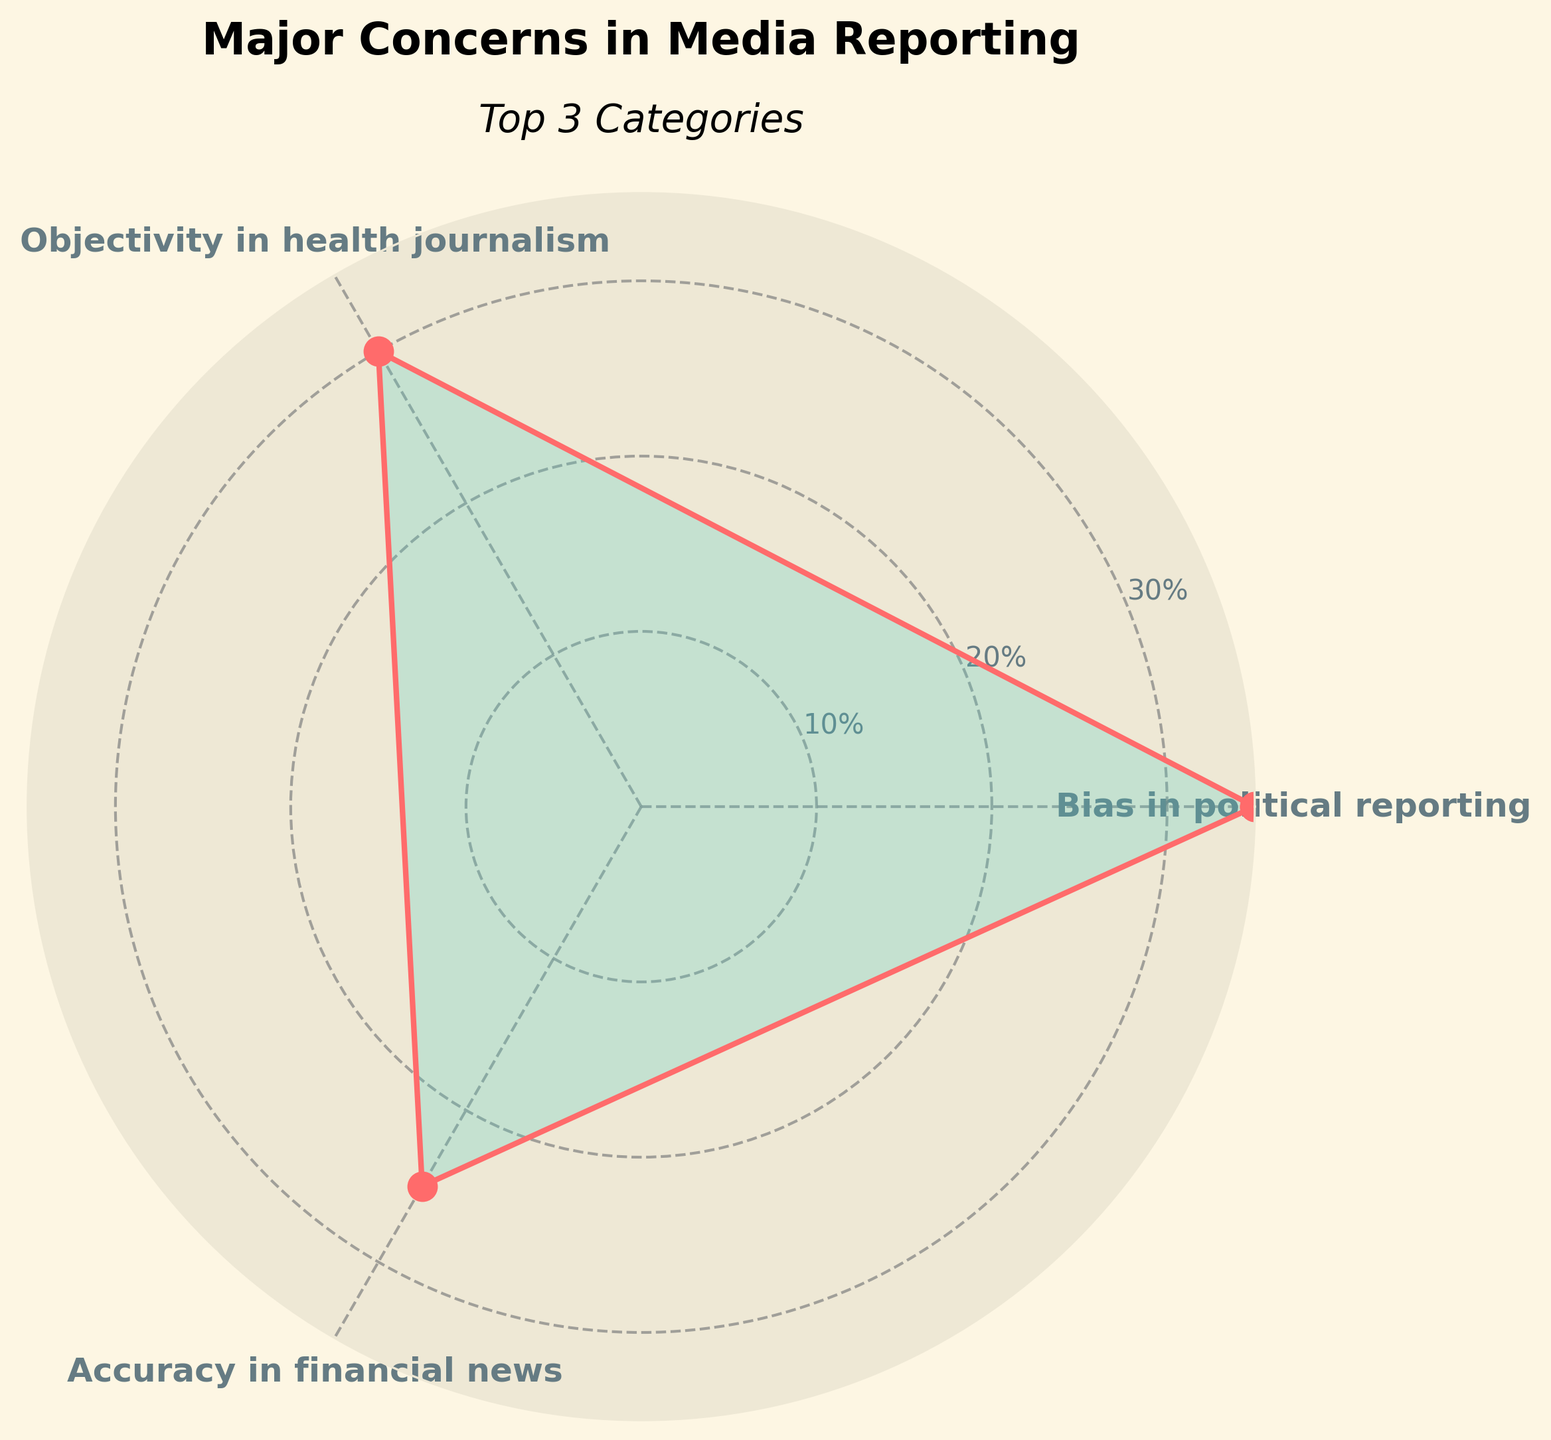What is the title of the plot? The title is displayed at the top of the plot. It reads "Major Concerns in Media Reporting."
Answer: Major Concerns in Media Reporting Which category has the highest concern value? The plot shows different angle segments pointing to the values, and the segment with the highest value concerns Bias in political reporting. The value for Bias in political reporting is 35.
Answer: Bias in political reporting What is the value for objectivity in health journalism? The value can be read directly from the plot where the angle label for objectivity in health journalism is located. The value in that segment reaches 30.
Answer: 30 What are the top three concerns shown in the plot? The plot visualizes concerns and displays the top three categories around the polar axis. The top three indicated are Bias in political reporting, Objectivity in health journalism, and Accuracy in financial news.
Answer: Bias in political reporting, Objectivity in health journalism, Accuracy in financial news What is the average value of the top three concerns? To find the average, sum the top three values and divide by three: (35 for Bias in political reporting) + (30 for Objectivity in health journalism) + (25 for Accuracy in financial news), which yields 90, then divide by 3.
Answer: 30 Which concern has the lowest value? The plot shows the radial lengths corresponding to the value for each category. The shortest length among the categories is for Bias in entertainment media.
Answer: Bias in entertainment media By how much does the concern for Bias in political reporting exceed Objectivity in health journalism? Subtract the value for Objectivity in health journalism (30) from the value for Bias in political reporting (35), resulting in 35 - 30.
Answer: 5 What is the color used to highlight the filled area beneath the plotted line? The plot uses a light seafoam green color fill beneath the plotted line connecting the category values around the polar chart.
Answer: seafoam green What is the purpose of the radial grid lines on the plot? The radial grid lines divide the plot into equal parts and provide reference points for estimating the value levels, aiding in visual comparison of the different category values.
Answer: Provide reference points Which category is positioned at roughly 90 degrees on the polar plot? On a polar plot, 90 degrees is represented by the rightmost angle facing horizontally. The category situated at that angle is Bias in political reporting.
Answer: Bias in political reporting 